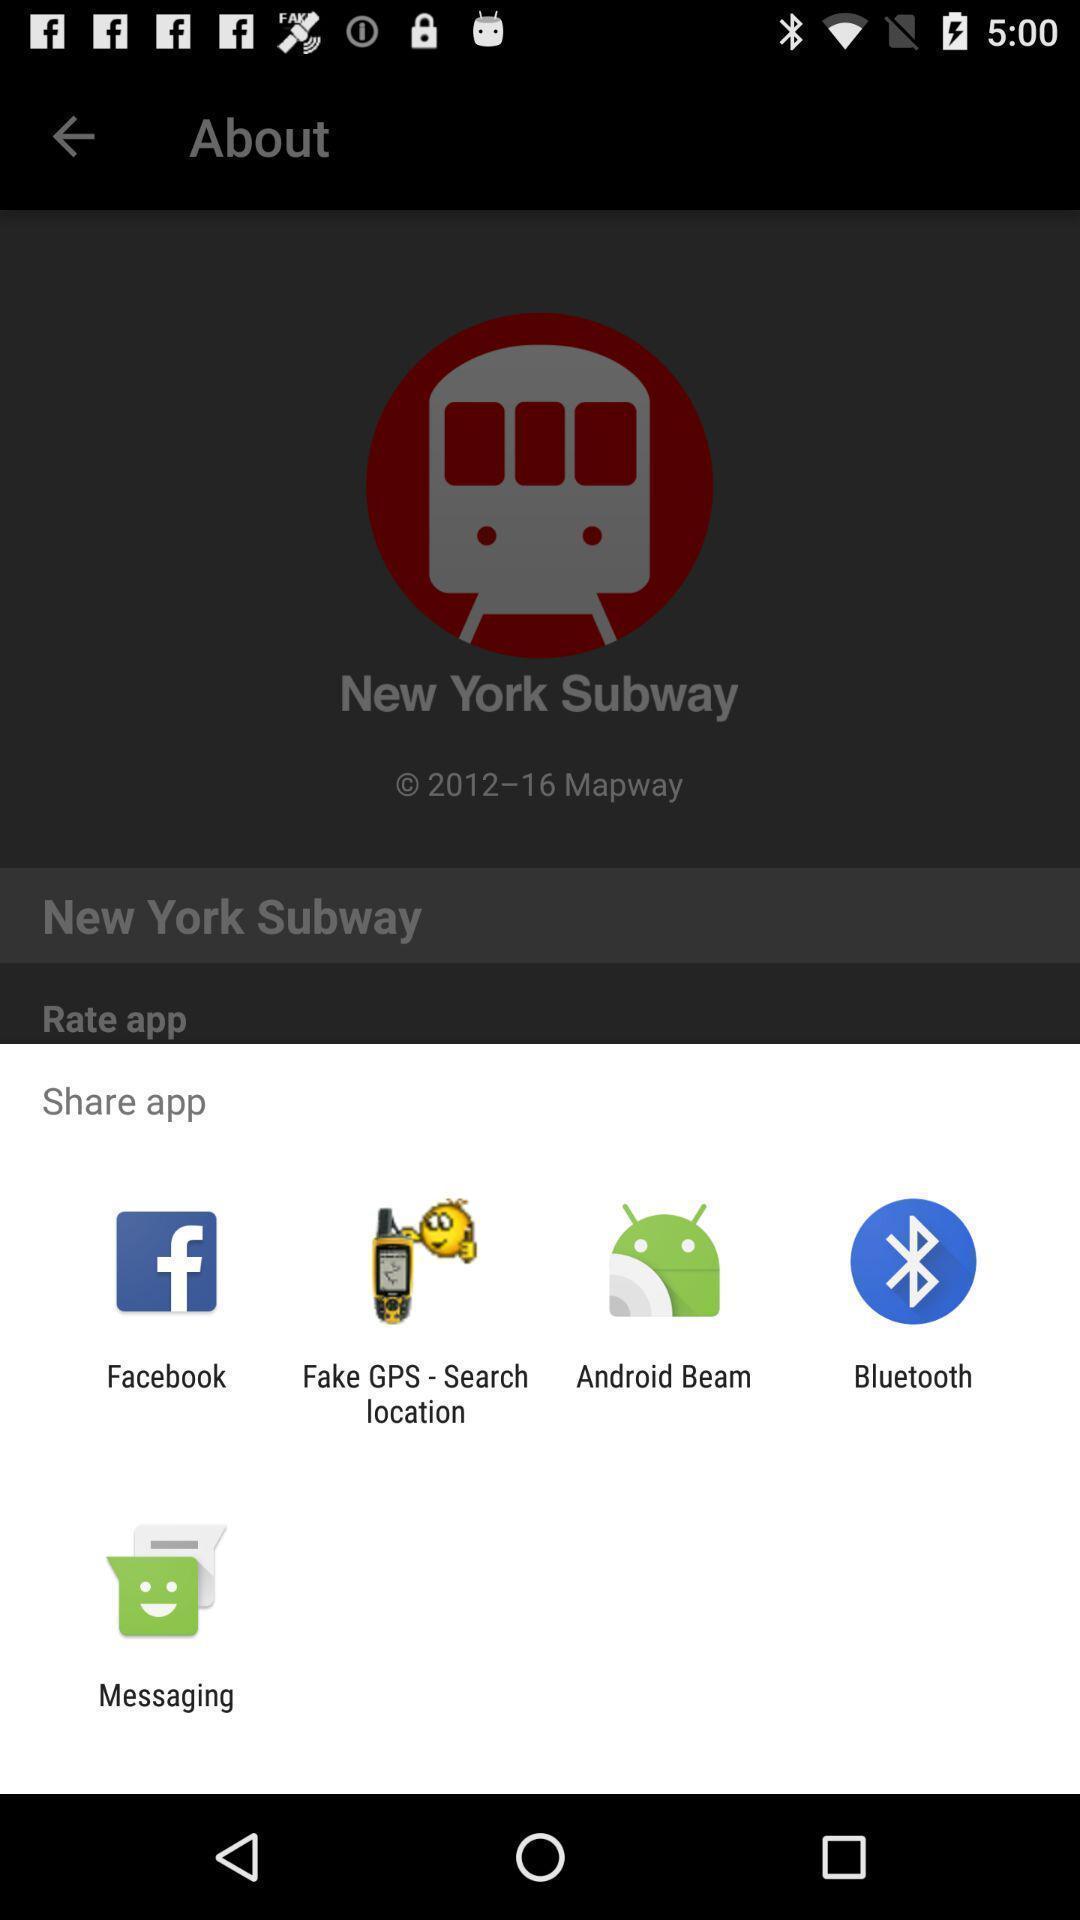Describe the visual elements of this screenshot. Pop-up showing multiple share options. 